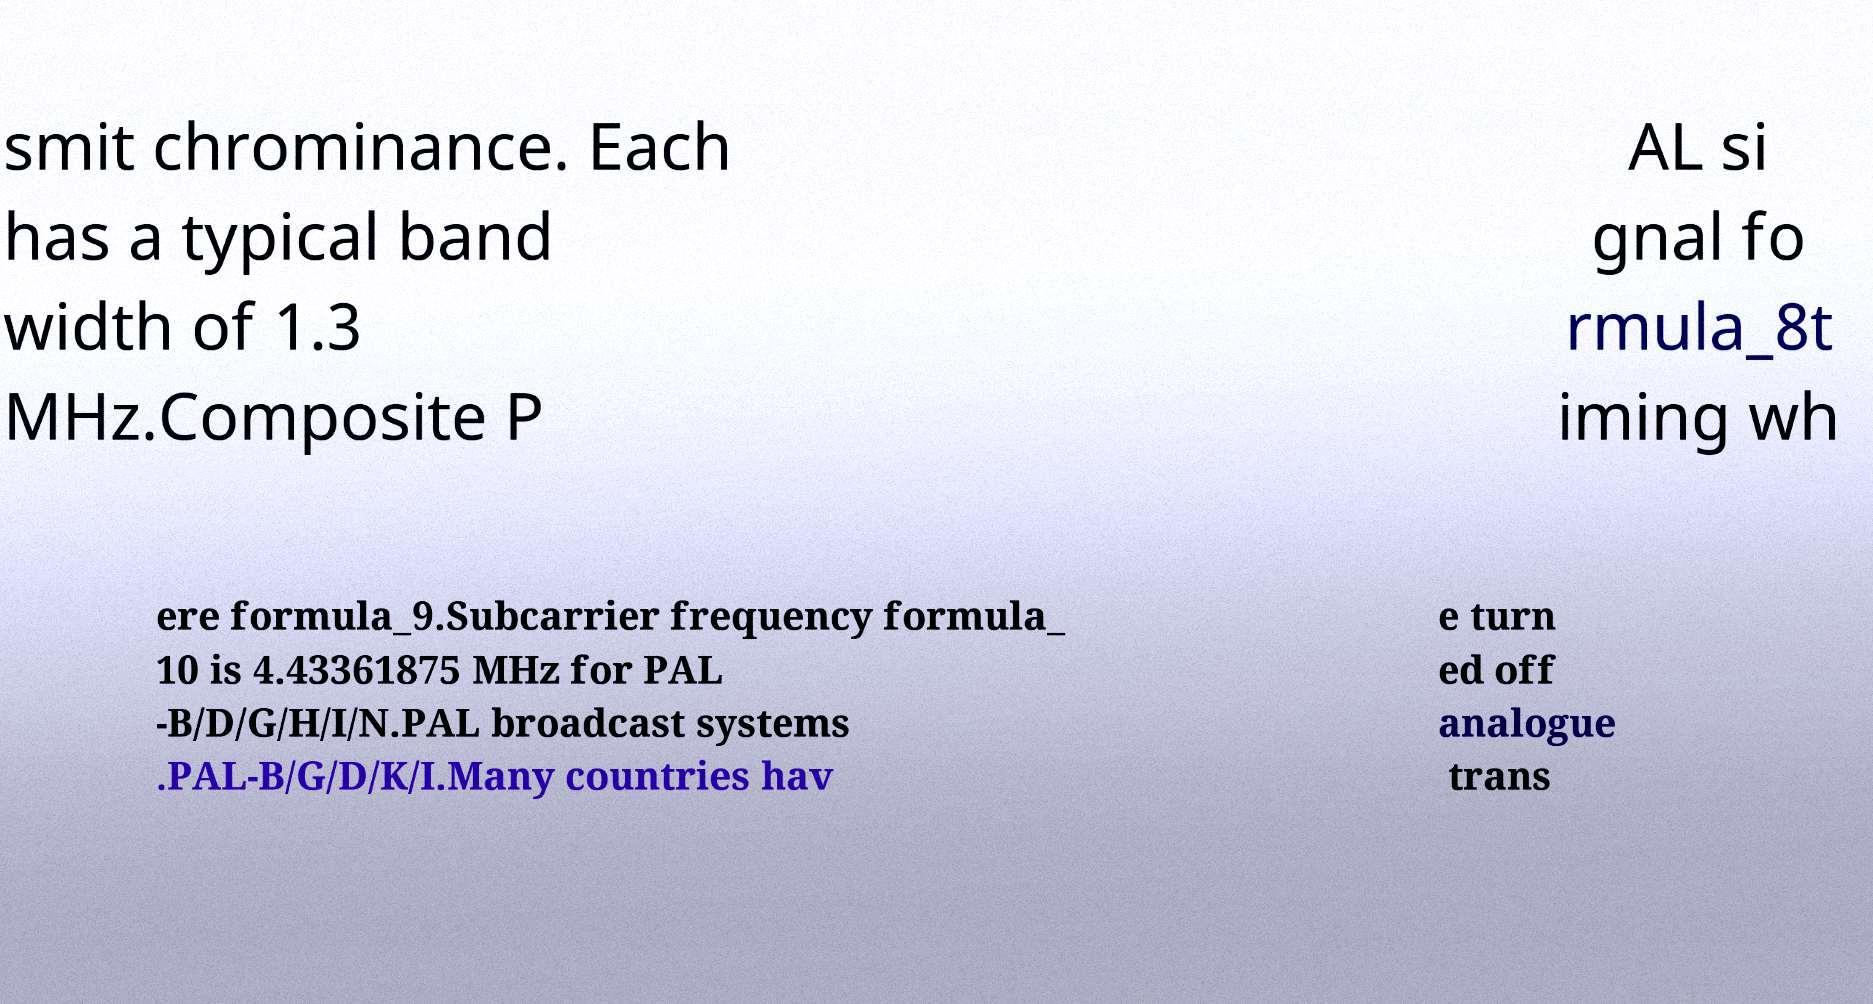Can you accurately transcribe the text from the provided image for me? smit chrominance. Each has a typical band width of 1.3 MHz.Composite P AL si gnal fo rmula_8t iming wh ere formula_9.Subcarrier frequency formula_ 10 is 4.43361875 MHz for PAL -B/D/G/H/I/N.PAL broadcast systems .PAL-B/G/D/K/I.Many countries hav e turn ed off analogue trans 